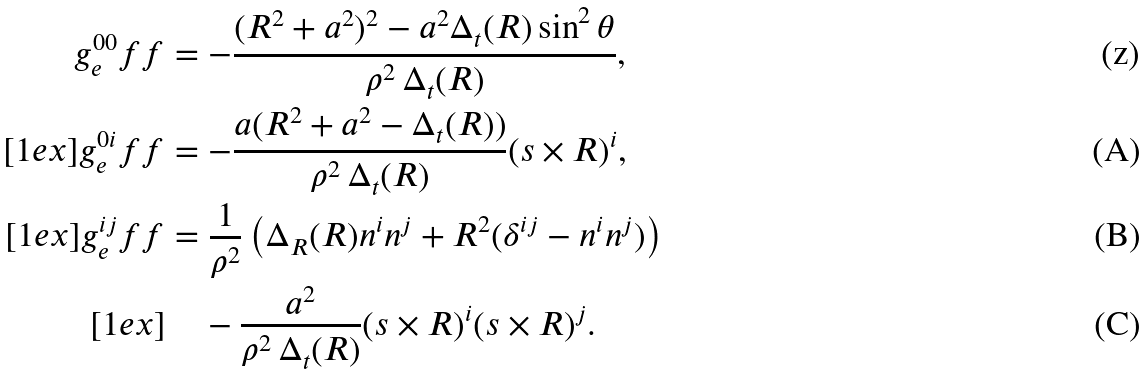Convert formula to latex. <formula><loc_0><loc_0><loc_500><loc_500>g ^ { 0 0 } _ { e } f f & = - \frac { ( R ^ { 2 } + a ^ { 2 } ) ^ { 2 } - a ^ { 2 } \Delta _ { t } ( R ) \sin ^ { 2 } \theta } { \rho ^ { 2 } \, \Delta _ { t } ( R ) } , \\ [ 1 e x ] g ^ { 0 i } _ { e } f f & = - \frac { a ( R ^ { 2 } + a ^ { 2 } - \Delta _ { t } ( R ) ) } { \rho ^ { 2 } \, \Delta _ { t } ( R ) } ( s \times R ) ^ { i } , \\ [ 1 e x ] g ^ { i j } _ { e } f f & = \frac { 1 } { \rho ^ { 2 } } \left ( \Delta _ { R } ( R ) n ^ { i } n ^ { j } + R ^ { 2 } ( \delta ^ { i j } - n ^ { i } n ^ { j } ) \right ) \\ [ 1 e x ] & \quad - \frac { a ^ { 2 } } { \rho ^ { 2 } \, \Delta _ { t } ( R ) } ( s \times R ) ^ { i } ( s \times R ) ^ { j } .</formula> 